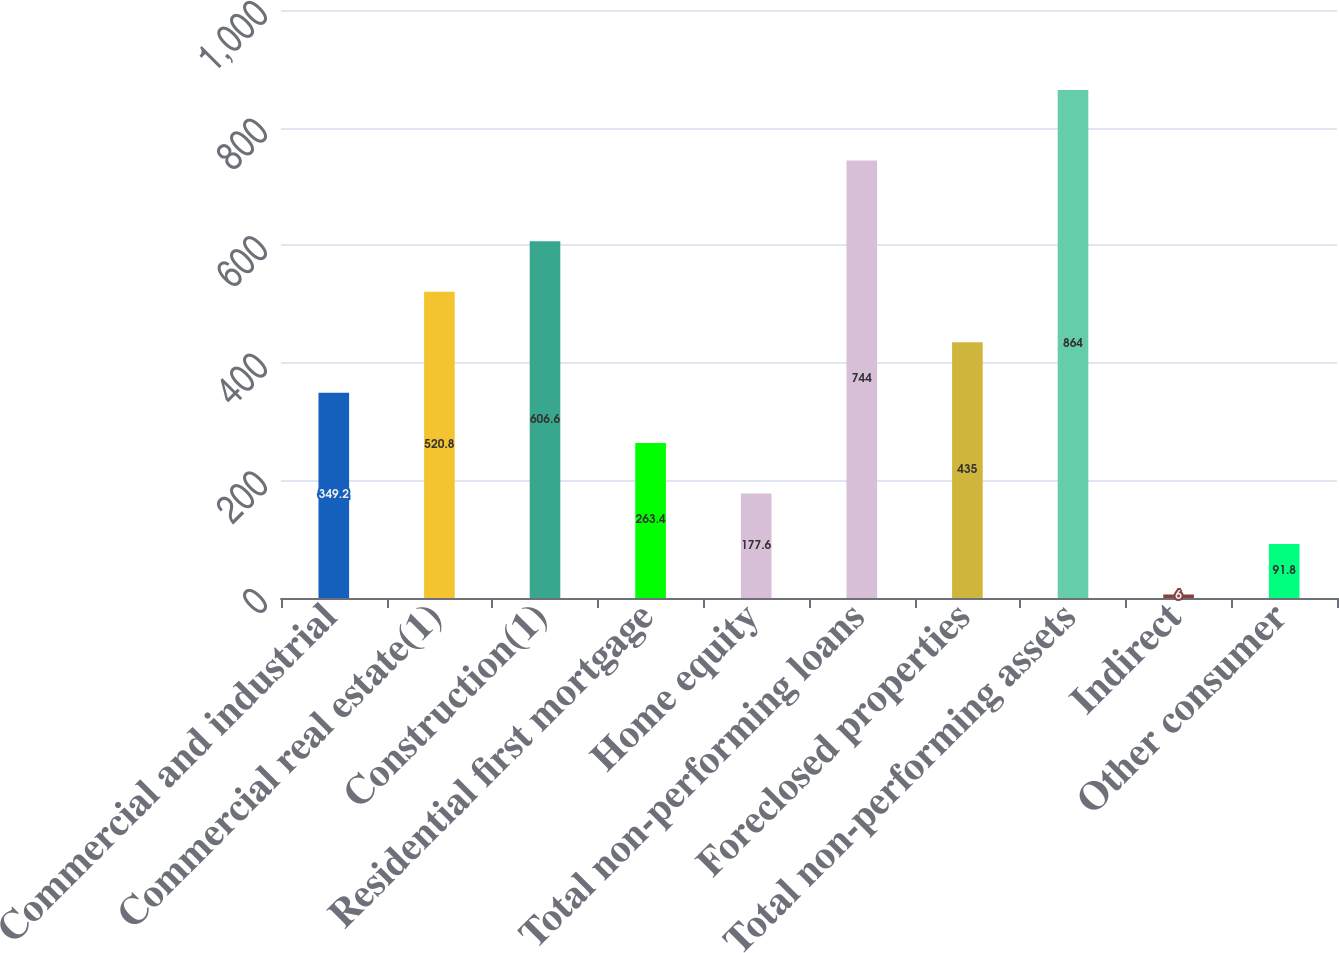Convert chart. <chart><loc_0><loc_0><loc_500><loc_500><bar_chart><fcel>Commercial and industrial<fcel>Commercial real estate(1)<fcel>Construction(1)<fcel>Residential first mortgage<fcel>Home equity<fcel>Total non-performing loans<fcel>Foreclosed properties<fcel>Total non-performing assets<fcel>Indirect<fcel>Other consumer<nl><fcel>349.2<fcel>520.8<fcel>606.6<fcel>263.4<fcel>177.6<fcel>744<fcel>435<fcel>864<fcel>6<fcel>91.8<nl></chart> 